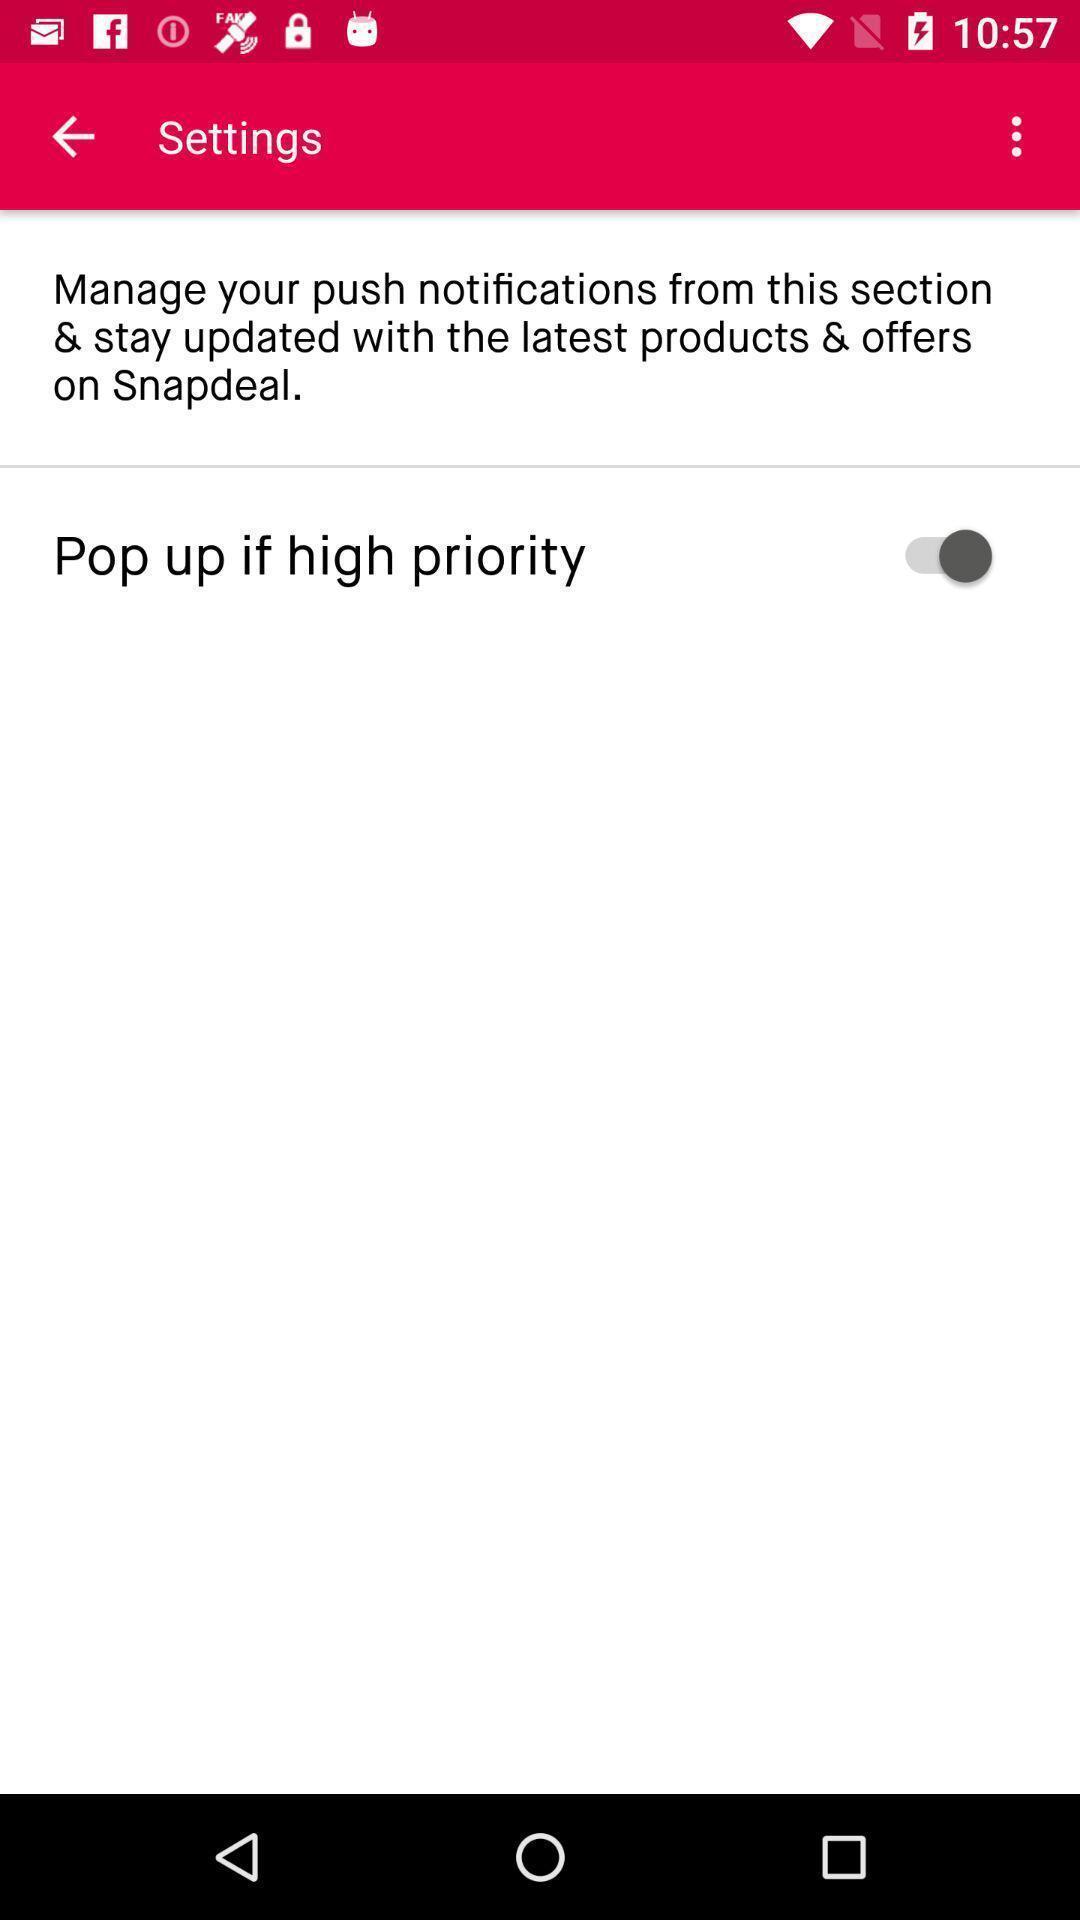What can you discern from this picture? Settings page of a shopping app. 